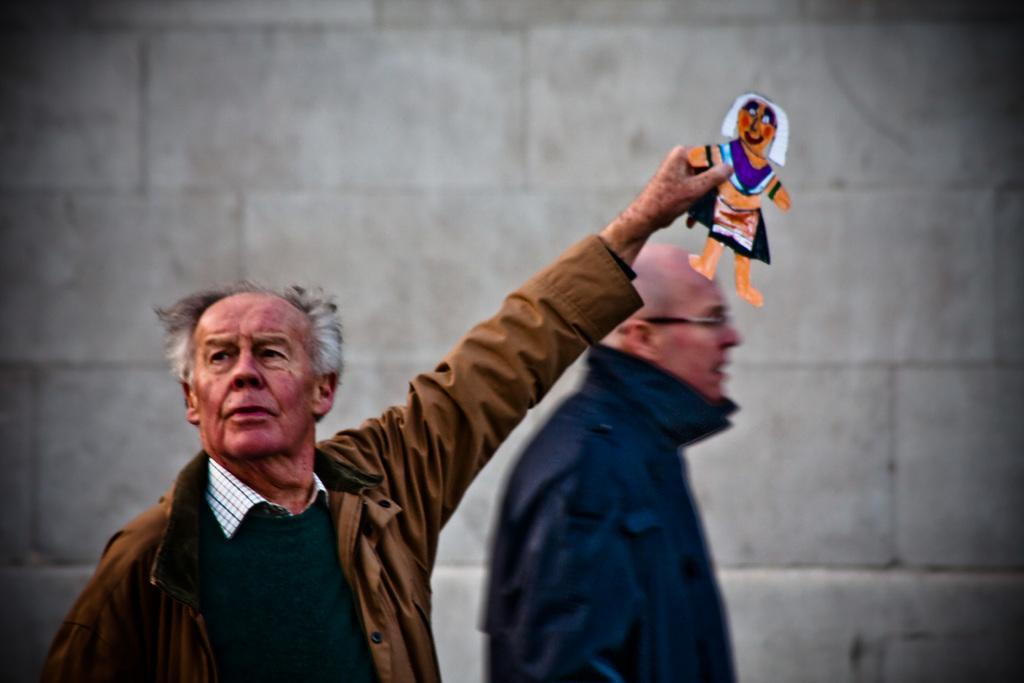What can be seen in the image? There are people standing in the image. What is the man holding in his hand? The man is holding a paper toy in his hand. What can be seen in the background of the image? There is a wall visible in the background of the image. What type of comb is the man using to make the paper toy in the image? There is no comb present in the image, and the man is not using a comb to make the paper toy. 